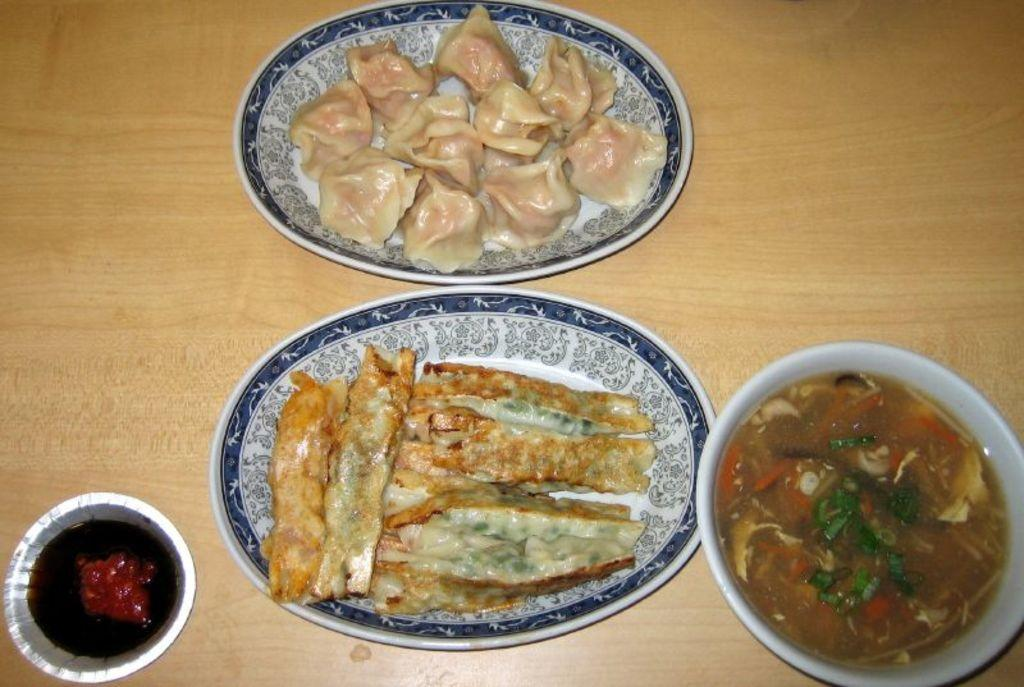What is present on the table in the image? There is food on the table. How many bowls are on the table? There are two bowls on the table. What type of food is on the plates? There is flesh on the plates. What material is the table made of? The table is made of wood. What type of voice can be heard coming from the food in the image? There is no voice coming from the food in the image, as food does not have the ability to produce sound. 